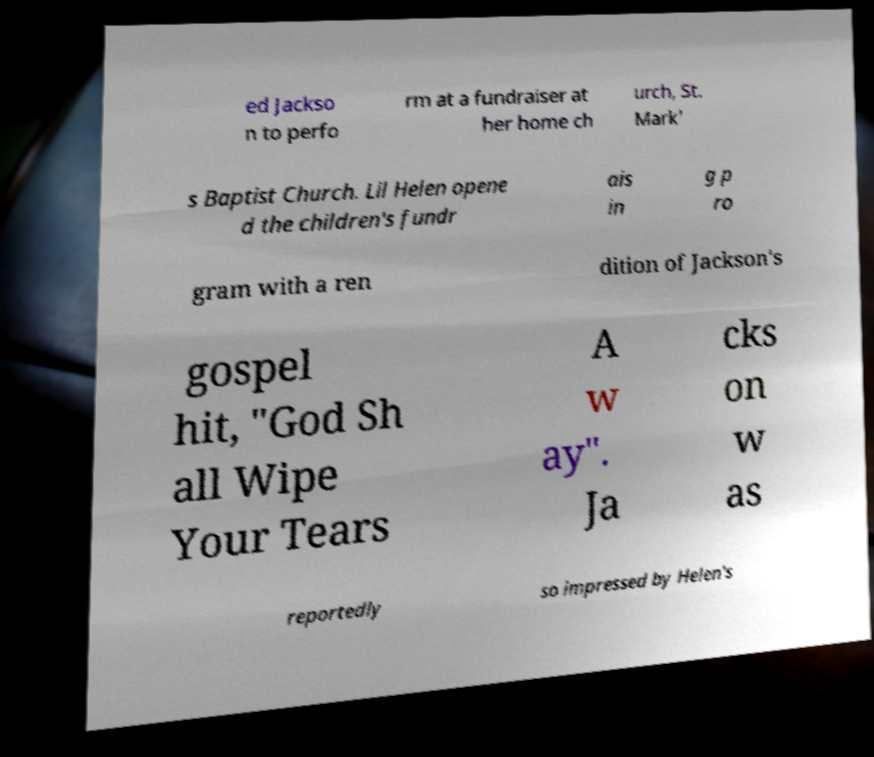For documentation purposes, I need the text within this image transcribed. Could you provide that? ed Jackso n to perfo rm at a fundraiser at her home ch urch, St. Mark' s Baptist Church. Lil Helen opene d the children's fundr ais in g p ro gram with a ren dition of Jackson's gospel hit, "God Sh all Wipe Your Tears A w ay". Ja cks on w as reportedly so impressed by Helen's 